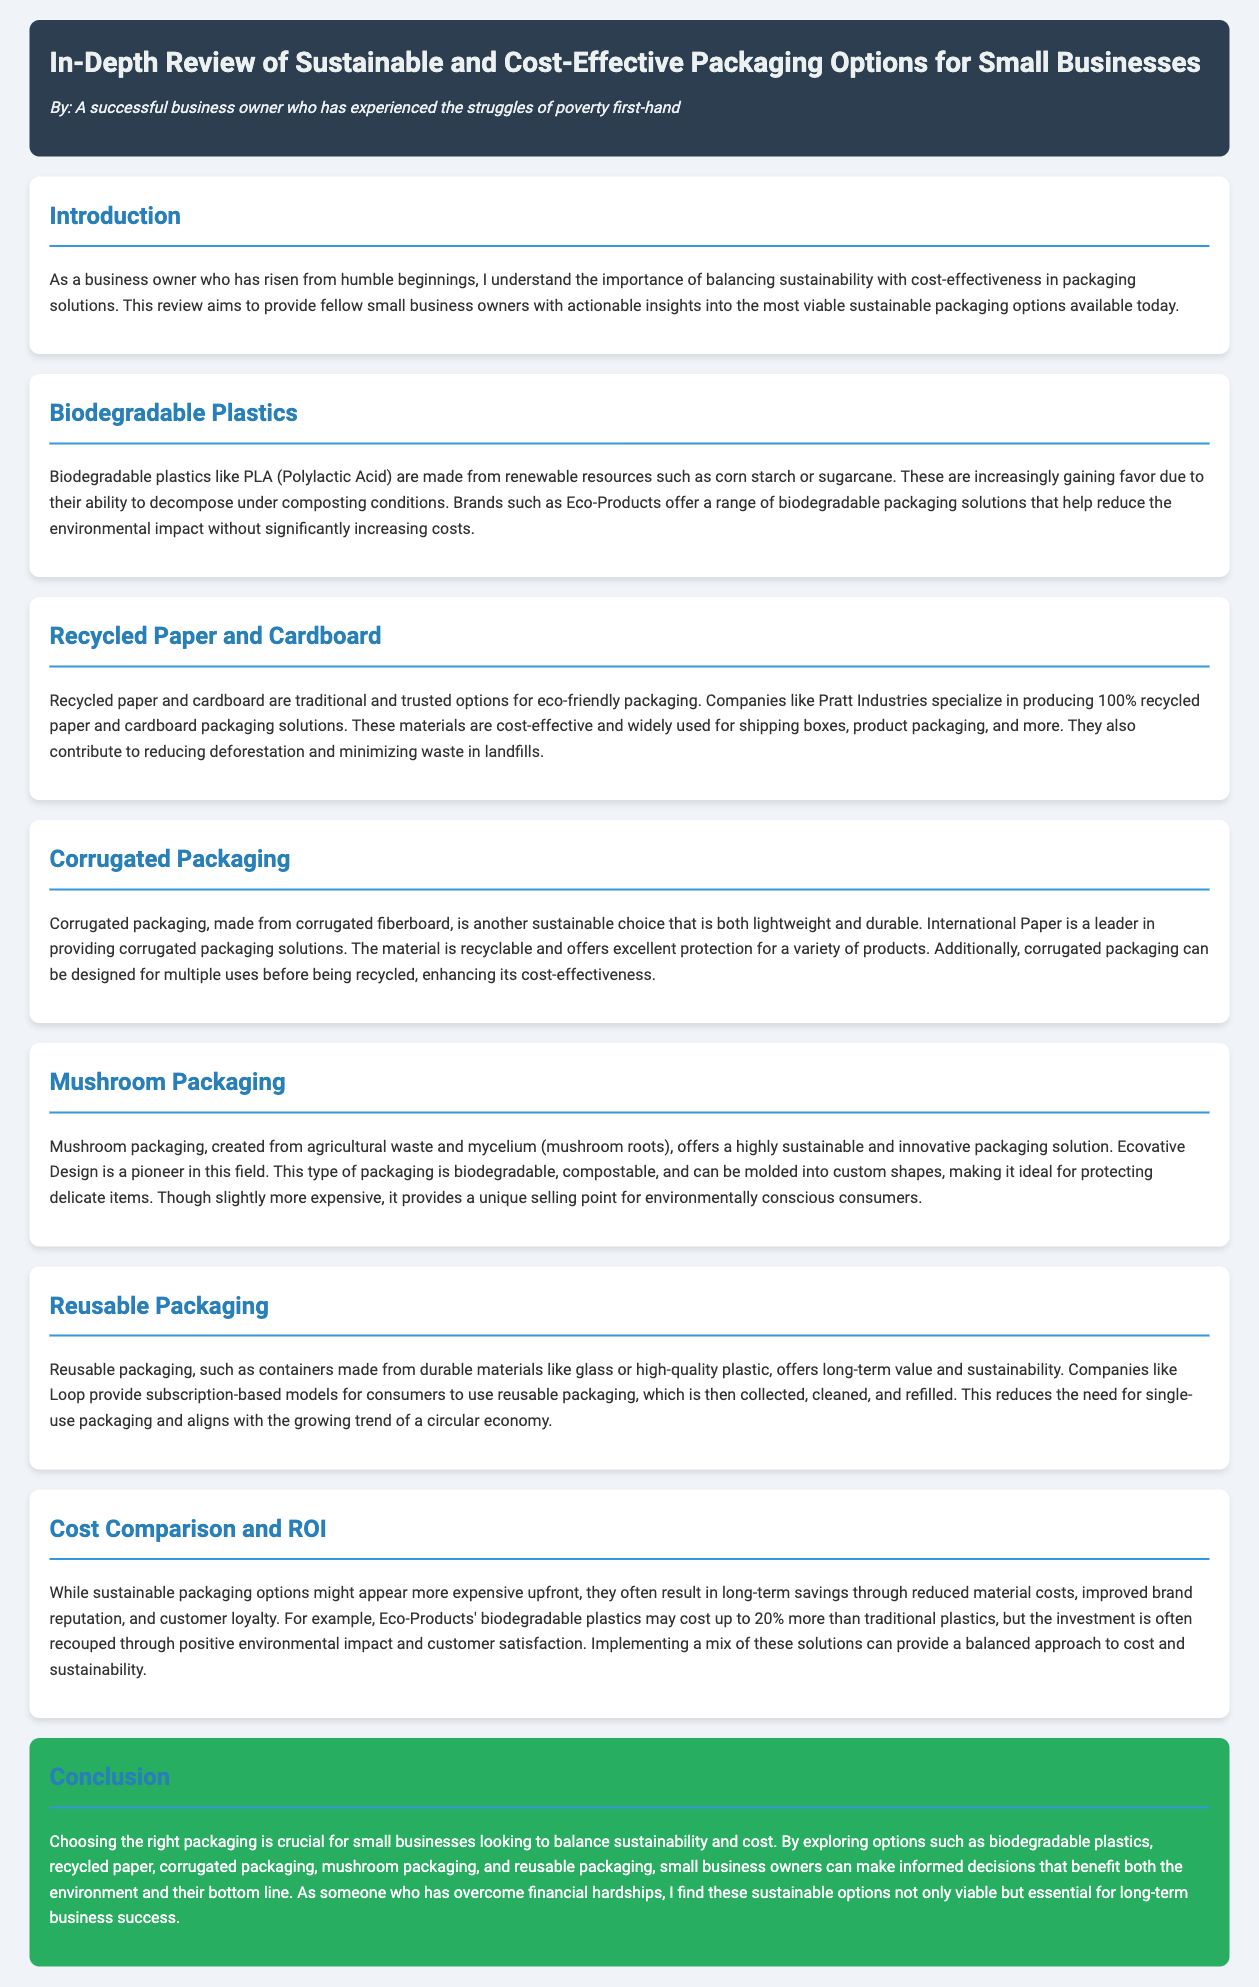what is the title of the document? The title of the document is prominently displayed at the top and reads "In-Depth Review of Sustainable and Cost-Effective Packaging Options for Small Businesses."
Answer: In-Depth Review of Sustainable and Cost-Effective Packaging Options for Small Businesses who is the author of the document? The author is mentioned in the header section of the document as "A successful business owner who has experienced the struggles of poverty first-hand."
Answer: A successful business owner who has experienced the struggles of poverty first-hand what biodegradable plastic is mentioned in the document? The document references PLA (Polylactic Acid) as a type of biodegradable plastic.
Answer: PLA (Polylactic Acid) which company specializes in producing 100% recycled paper and cardboard packaging? The document states that Pratt Industries specializes in producing 100% recycled paper and cardboard packaging solutions.
Answer: Pratt Industries what are the two main benefits of using reusable packaging as per the document? The document highlights long-term value and sustainability as the two main benefits of using reusable packaging.
Answer: Long-term value and sustainability what is the potential increased cost of biodegradable plastics compared to traditional plastics? The document specifies that Eco-Products' biodegradable plastics may cost up to 20% more than traditional plastics.
Answer: 20% which sustainable packaging option is created from agricultural waste? The document specifies mushroom packaging as being created from agricultural waste and mycelium.
Answer: Mushroom packaging what is the main conclusion regarding the choice of packaging? The conclusion states that choosing the right packaging is crucial for small businesses looking to balance sustainability and cost.
Answer: Choosing the right packaging is crucial for small businesses looking to balance sustainability and cost 